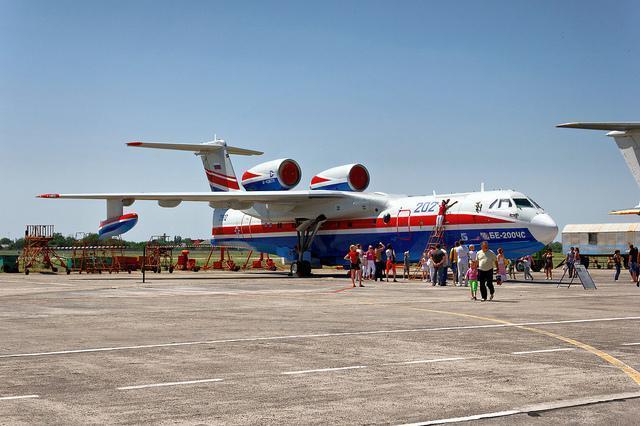How many different colors does the plane have?
Give a very brief answer. 3. 